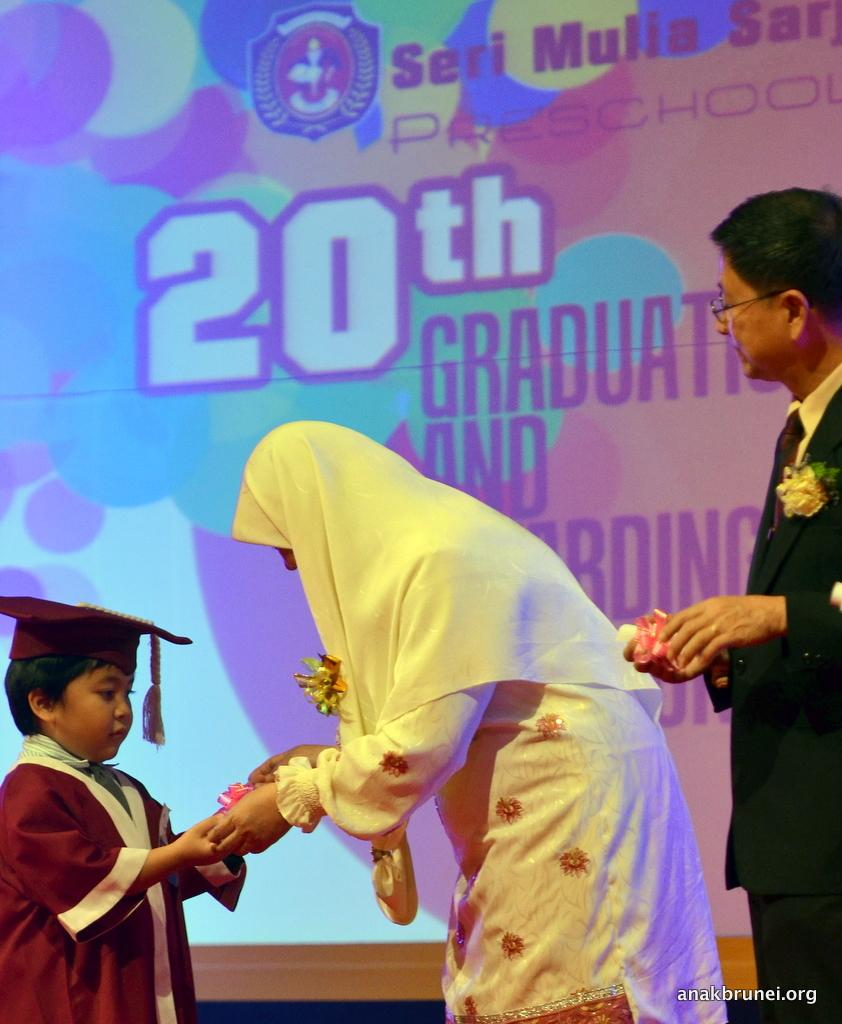How many people are present in the image? There are three people in the image: a man, a woman, and a child. What are the people in the image holding? The man, woman, and child are holding objects. What can be seen in the background of the image? There is a display screen in the background of the image. What is visible on the display screen? There is text visible on the display screen. What type of quilt is being used to move the can in the image? There is no quilt or can present in the image. 